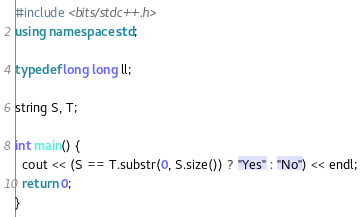Convert code to text. <code><loc_0><loc_0><loc_500><loc_500><_C++_>#include <bits/stdc++.h>
using namespace std;

typedef long long ll;

string S, T;

int main() {
  cout << (S == T.substr(0, S.size()) ? "Yes" : "No") << endl;
  return 0;
}
</code> 